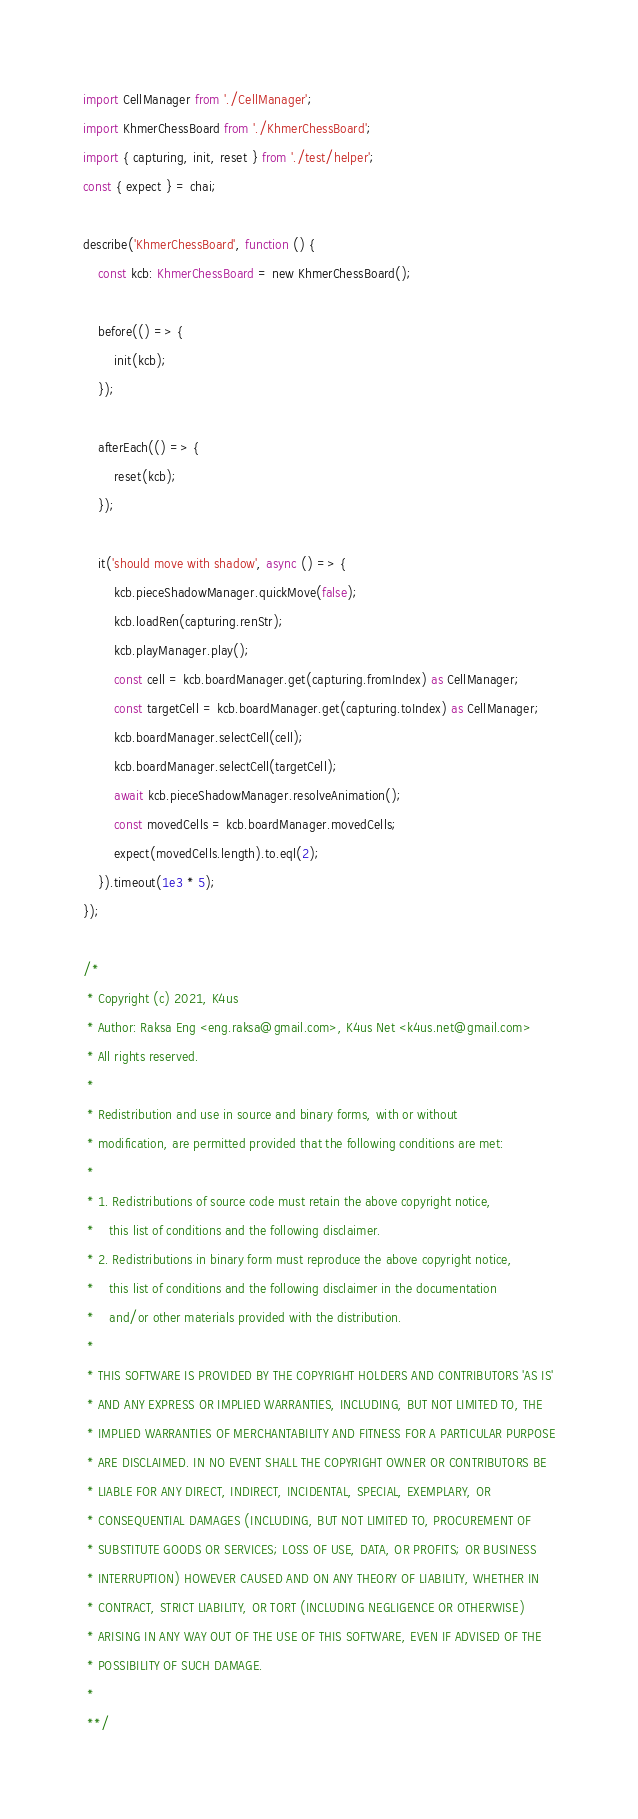Convert code to text. <code><loc_0><loc_0><loc_500><loc_500><_TypeScript_>import CellManager from './CellManager';
import KhmerChessBoard from './KhmerChessBoard';
import { capturing, init, reset } from './test/helper';
const { expect } = chai;

describe('KhmerChessBoard', function () {
    const kcb: KhmerChessBoard = new KhmerChessBoard();

    before(() => {
        init(kcb);
    });

    afterEach(() => {
        reset(kcb);
    });

    it('should move with shadow', async () => {
        kcb.pieceShadowManager.quickMove(false);
        kcb.loadRen(capturing.renStr);
        kcb.playManager.play();
        const cell = kcb.boardManager.get(capturing.fromIndex) as CellManager;
        const targetCell = kcb.boardManager.get(capturing.toIndex) as CellManager;
        kcb.boardManager.selectCell(cell);
        kcb.boardManager.selectCell(targetCell);
        await kcb.pieceShadowManager.resolveAnimation();
        const movedCells = kcb.boardManager.movedCells;
        expect(movedCells.length).to.eql(2);
    }).timeout(1e3 * 5);
});

/*
 * Copyright (c) 2021, K4us
 * Author: Raksa Eng <eng.raksa@gmail.com>, K4us Net <k4us.net@gmail.com>
 * All rights reserved.
 *
 * Redistribution and use in source and binary forms, with or without
 * modification, are permitted provided that the following conditions are met:
 *
 * 1. Redistributions of source code must retain the above copyright notice,
 *    this list of conditions and the following disclaimer.
 * 2. Redistributions in binary form must reproduce the above copyright notice,
 *    this list of conditions and the following disclaimer in the documentation
 *    and/or other materials provided with the distribution.
 *
 * THIS SOFTWARE IS PROVIDED BY THE COPYRIGHT HOLDERS AND CONTRIBUTORS 'AS IS'
 * AND ANY EXPRESS OR IMPLIED WARRANTIES, INCLUDING, BUT NOT LIMITED TO, THE
 * IMPLIED WARRANTIES OF MERCHANTABILITY AND FITNESS FOR A PARTICULAR PURPOSE
 * ARE DISCLAIMED. IN NO EVENT SHALL THE COPYRIGHT OWNER OR CONTRIBUTORS BE
 * LIABLE FOR ANY DIRECT, INDIRECT, INCIDENTAL, SPECIAL, EXEMPLARY, OR
 * CONSEQUENTIAL DAMAGES (INCLUDING, BUT NOT LIMITED TO, PROCUREMENT OF
 * SUBSTITUTE GOODS OR SERVICES; LOSS OF USE, DATA, OR PROFITS; OR BUSINESS
 * INTERRUPTION) HOWEVER CAUSED AND ON ANY THEORY OF LIABILITY, WHETHER IN
 * CONTRACT, STRICT LIABILITY, OR TORT (INCLUDING NEGLIGENCE OR OTHERWISE)
 * ARISING IN ANY WAY OUT OF THE USE OF THIS SOFTWARE, EVEN IF ADVISED OF THE
 * POSSIBILITY OF SUCH DAMAGE.
 *
 **/</code> 